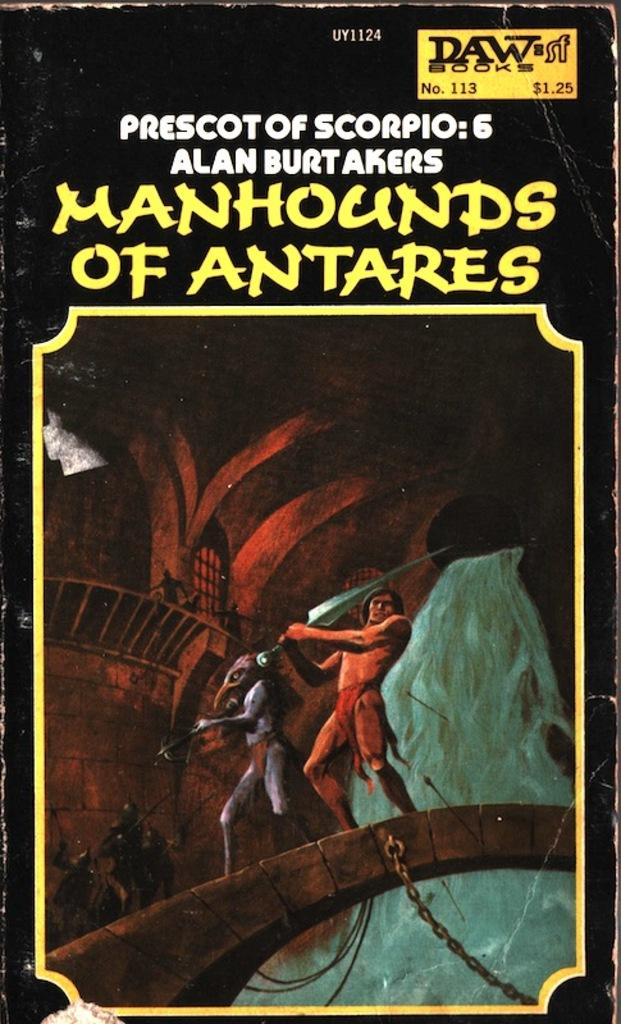Provide a one-sentence caption for the provided image. A book that is titled Manhounds of Antares. 